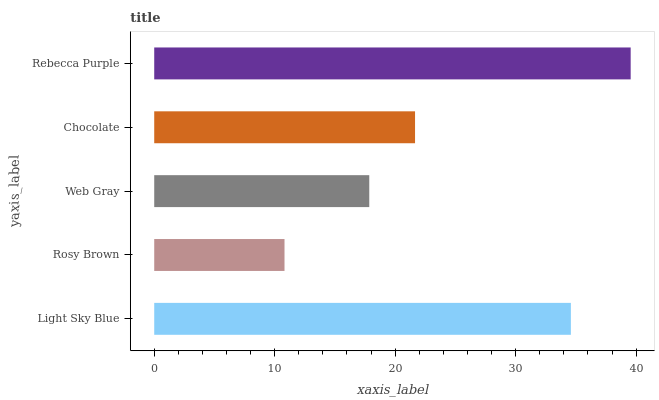Is Rosy Brown the minimum?
Answer yes or no. Yes. Is Rebecca Purple the maximum?
Answer yes or no. Yes. Is Web Gray the minimum?
Answer yes or no. No. Is Web Gray the maximum?
Answer yes or no. No. Is Web Gray greater than Rosy Brown?
Answer yes or no. Yes. Is Rosy Brown less than Web Gray?
Answer yes or no. Yes. Is Rosy Brown greater than Web Gray?
Answer yes or no. No. Is Web Gray less than Rosy Brown?
Answer yes or no. No. Is Chocolate the high median?
Answer yes or no. Yes. Is Chocolate the low median?
Answer yes or no. Yes. Is Web Gray the high median?
Answer yes or no. No. Is Rebecca Purple the low median?
Answer yes or no. No. 